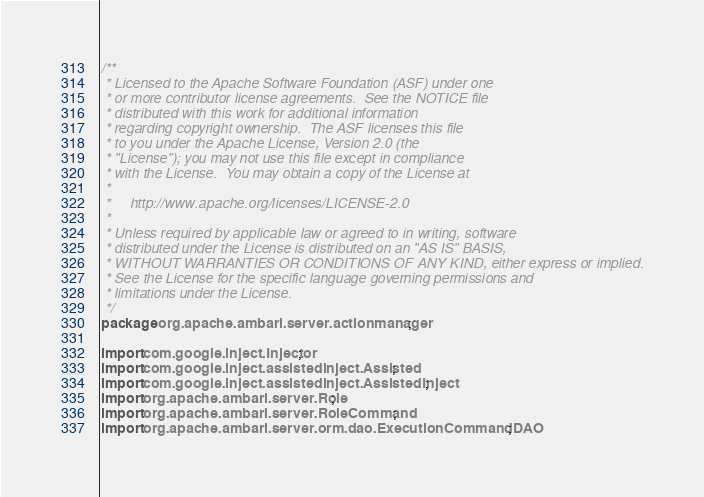Convert code to text. <code><loc_0><loc_0><loc_500><loc_500><_Java_>/**
 * Licensed to the Apache Software Foundation (ASF) under one
 * or more contributor license agreements.  See the NOTICE file
 * distributed with this work for additional information
 * regarding copyright ownership.  The ASF licenses this file
 * to you under the Apache License, Version 2.0 (the
 * "License"); you may not use this file except in compliance
 * with the License.  You may obtain a copy of the License at
 *
 *     http://www.apache.org/licenses/LICENSE-2.0
 *
 * Unless required by applicable law or agreed to in writing, software
 * distributed under the License is distributed on an "AS IS" BASIS,
 * WITHOUT WARRANTIES OR CONDITIONS OF ANY KIND, either express or implied.
 * See the License for the specific language governing permissions and
 * limitations under the License.
 */
package org.apache.ambari.server.actionmanager;

import com.google.inject.Injector;
import com.google.inject.assistedinject.Assisted;
import com.google.inject.assistedinject.AssistedInject;
import org.apache.ambari.server.Role;
import org.apache.ambari.server.RoleCommand;
import org.apache.ambari.server.orm.dao.ExecutionCommandDAO;</code> 